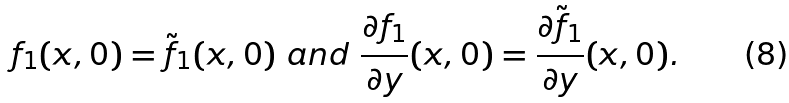Convert formula to latex. <formula><loc_0><loc_0><loc_500><loc_500>f _ { 1 } ( x , 0 ) = \tilde { f } _ { 1 } ( x , 0 ) \ a n d \ \frac { \partial f _ { 1 } } { \partial y } ( x , 0 ) = \frac { \partial \tilde { f } _ { 1 } } { \partial y } ( x , 0 ) .</formula> 